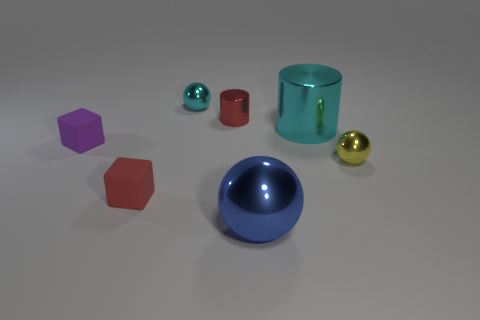Subtract all large blue metal spheres. How many spheres are left? 2 Subtract 1 spheres. How many spheres are left? 2 Add 1 small shiny cylinders. How many objects exist? 8 Subtract all blocks. How many objects are left? 5 Subtract all purple balls. Subtract all gray blocks. How many balls are left? 3 Subtract all brown things. Subtract all tiny metallic cylinders. How many objects are left? 6 Add 2 tiny purple rubber objects. How many tiny purple rubber objects are left? 3 Add 1 small blue rubber balls. How many small blue rubber balls exist? 1 Subtract 0 yellow cylinders. How many objects are left? 7 